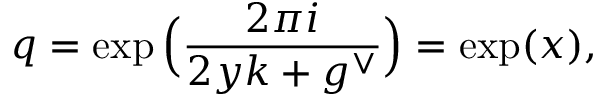<formula> <loc_0><loc_0><loc_500><loc_500>q = \exp \left ( \frac { 2 \pi i } { 2 y k + g ^ { \vee } } \right ) = \exp ( x ) ,</formula> 